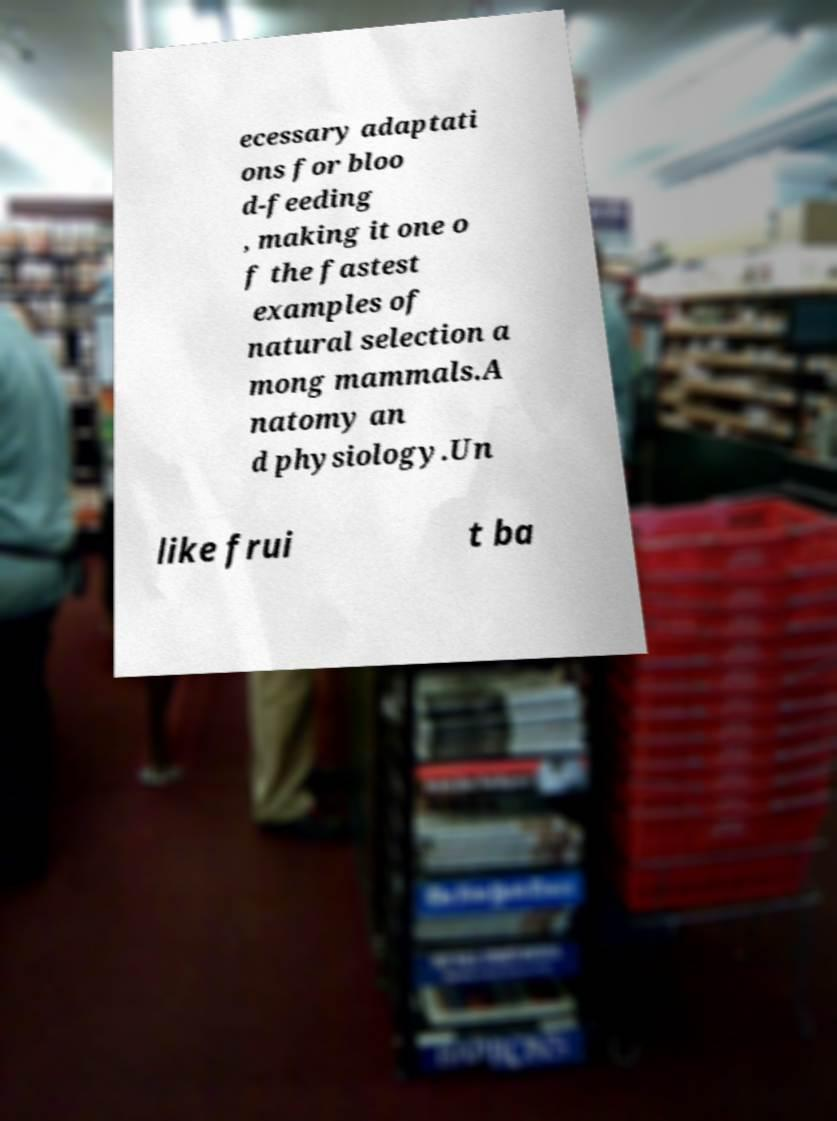Please identify and transcribe the text found in this image. ecessary adaptati ons for bloo d-feeding , making it one o f the fastest examples of natural selection a mong mammals.A natomy an d physiology.Un like frui t ba 